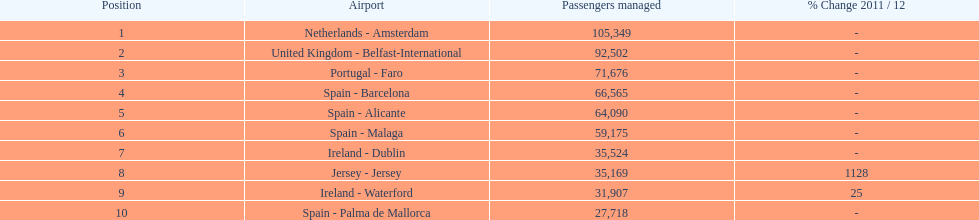Looking at the top 10 busiest routes to and from london southend airport what is the average number of passengers handled? 58,967.5. 